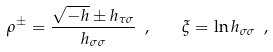<formula> <loc_0><loc_0><loc_500><loc_500>\rho ^ { \pm } = \frac { \sqrt { - h } \pm h _ { \tau \sigma } } { h _ { \sigma \sigma } } \ , \quad \xi = \ln h _ { \sigma \sigma } \ ,</formula> 